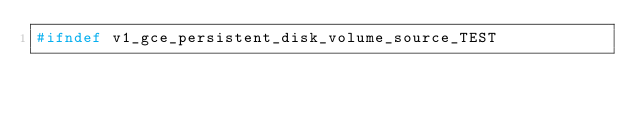<code> <loc_0><loc_0><loc_500><loc_500><_C_>#ifndef v1_gce_persistent_disk_volume_source_TEST</code> 